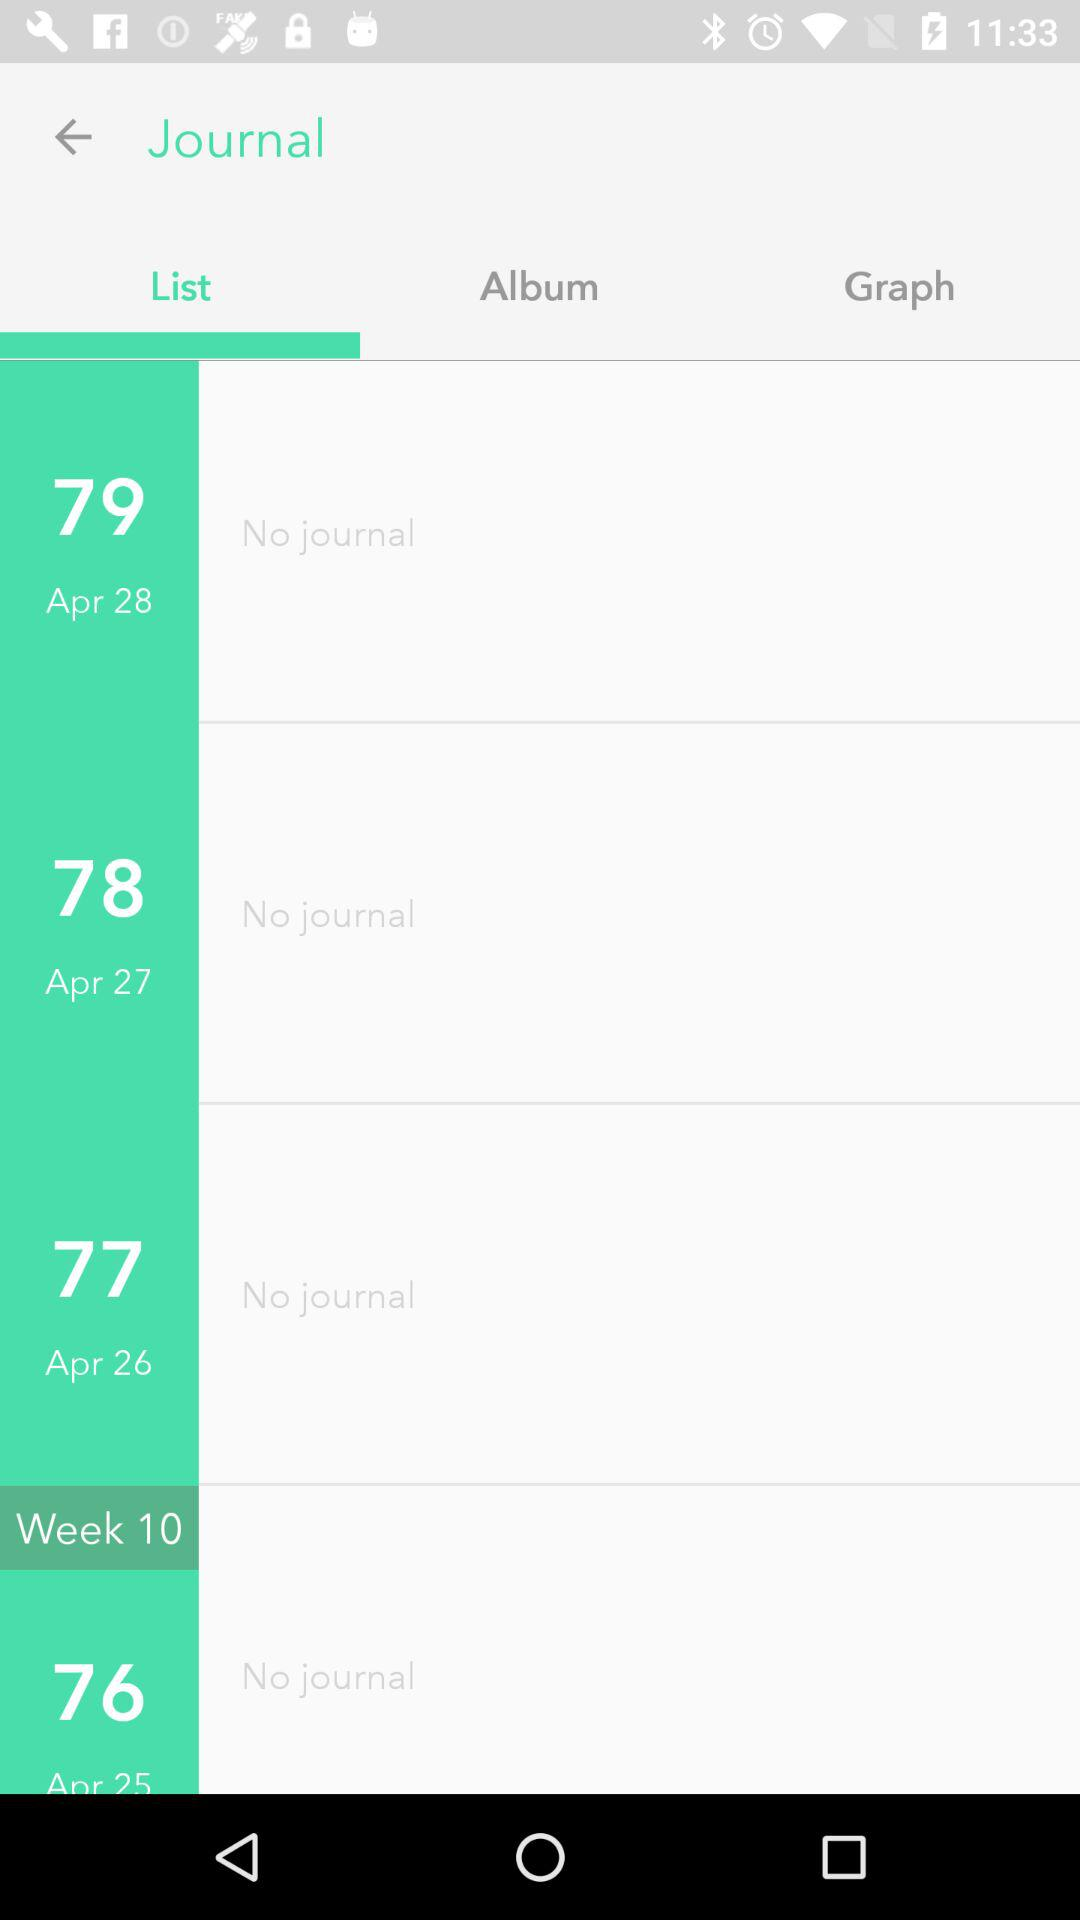What is the number of lists on April 26? There are 77 lists. 